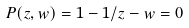Convert formula to latex. <formula><loc_0><loc_0><loc_500><loc_500>P ( z , w ) = 1 - 1 / z - w = 0</formula> 